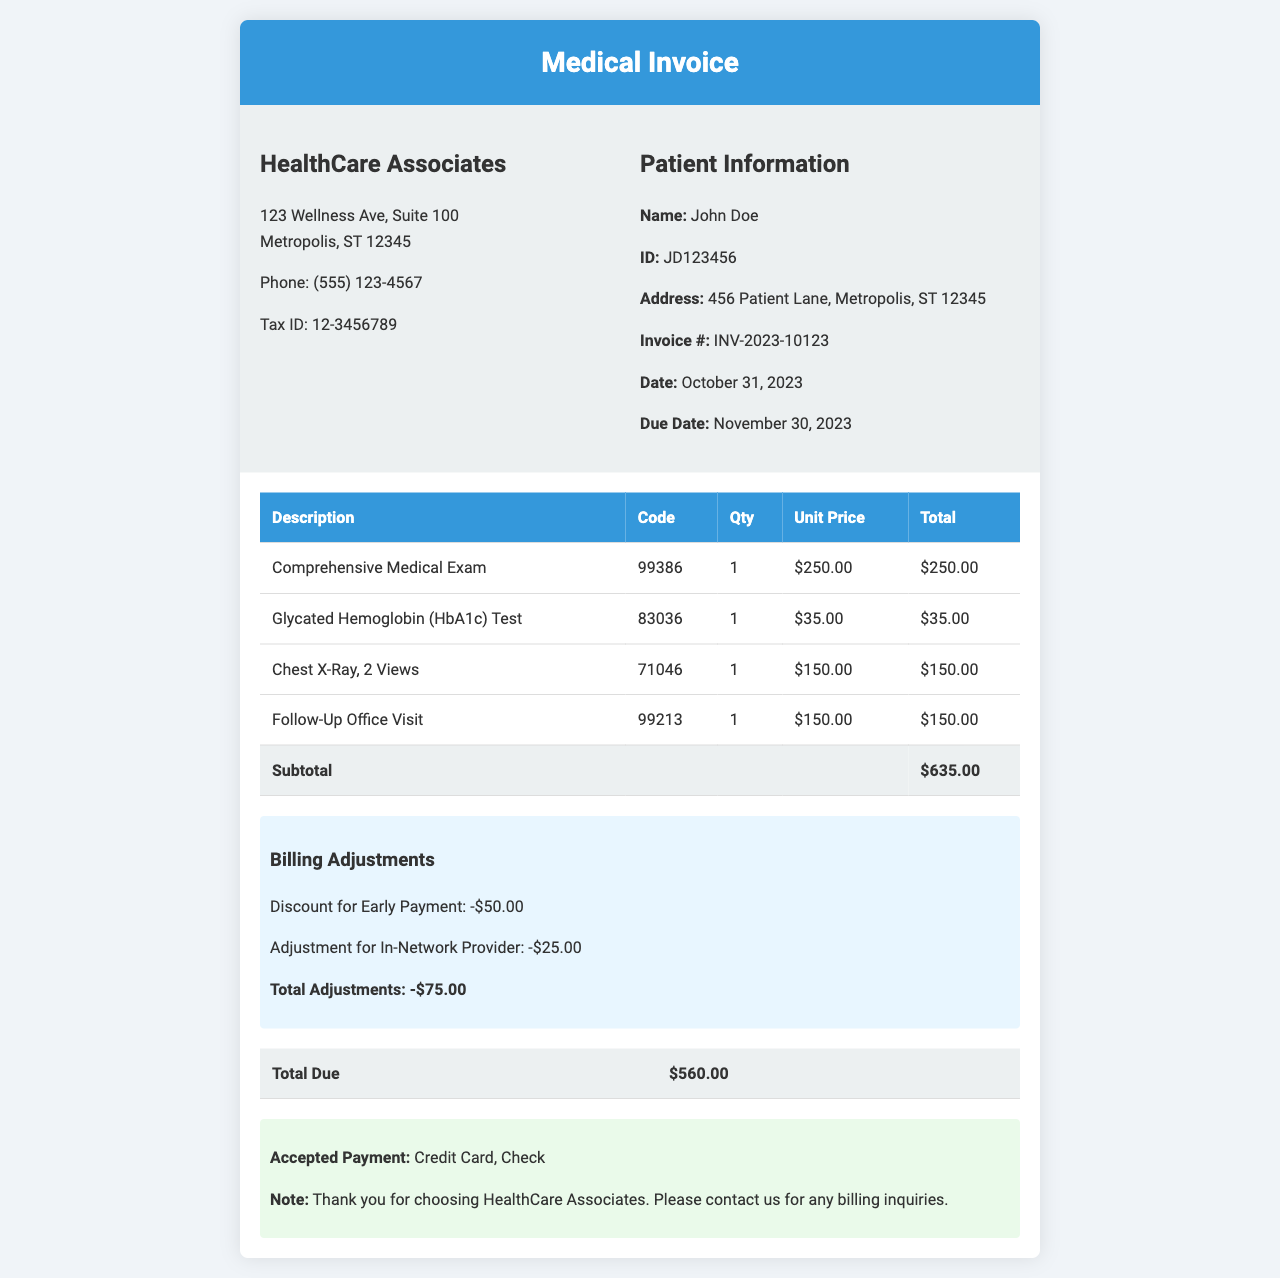what is the name of the provider? The provider's name is listed at the top of the invoice under provider information.
Answer: HealthCare Associates what is the patient ID? The patient ID is found in the patient information section of the invoice.
Answer: JD123456 what is the due date for payment? The due date is specified in the invoice details section.
Answer: November 30, 2023 how many tests were performed? The number of tests corresponds to the rows listed in the services rendered table.
Answer: 4 what is the total amount of the adjustments? The total adjustments amount is noted in the billing adjustments section.
Answer: -$75.00 what is the subtotal of the services rendered? The subtotal is the total before adjustments, seen in the total row of the services rendered table.
Answer: $635.00 what is the total due after adjustments? The total due is calculated after applying the adjustments to the subtotal, found in the total due row.
Answer: $560.00 what is the code for the Comprehensive Medical Exam? The code is listed next to the description of the service in the invoice body.
Answer: 99386 how is the total due amount paid? The accepted payment methods are stated in the payment notes section.
Answer: Credit Card, Check 